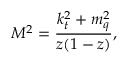Convert formula to latex. <formula><loc_0><loc_0><loc_500><loc_500>M ^ { 2 } = \frac { k _ { t } ^ { 2 } + m _ { q } ^ { 2 } } { z ( 1 - z ) } ,</formula> 